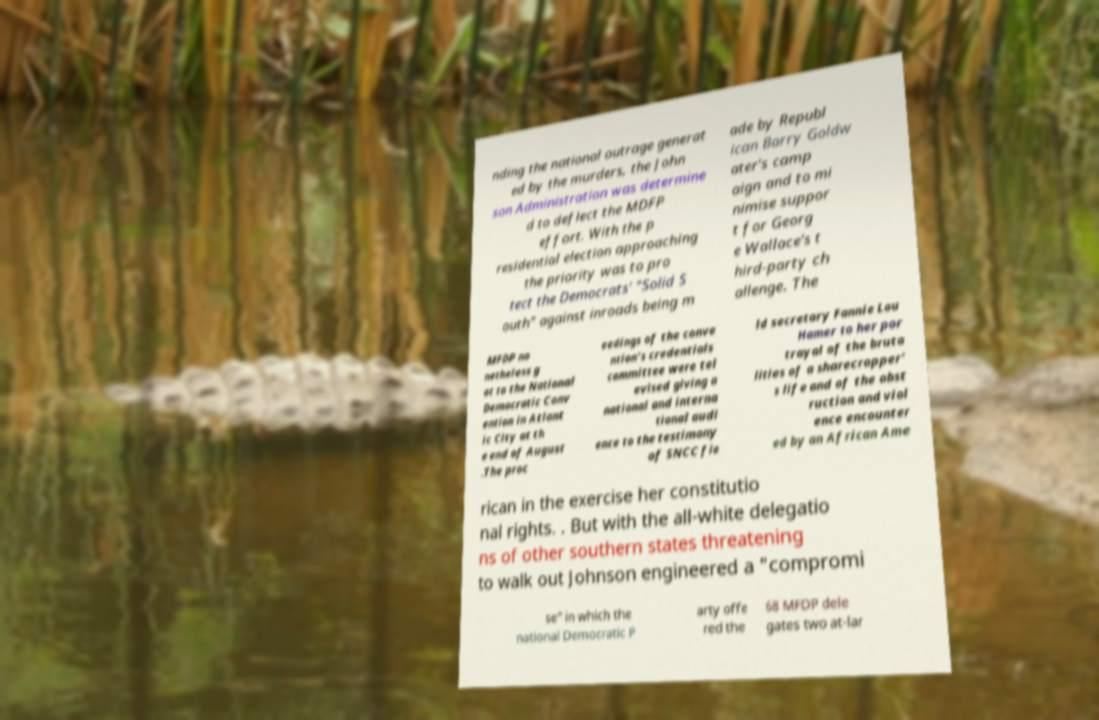Can you read and provide the text displayed in the image?This photo seems to have some interesting text. Can you extract and type it out for me? nding the national outrage generat ed by the murders, the John son Administration was determine d to deflect the MDFP effort. With the p residential election approaching the priority was to pro tect the Democrats' "Solid S outh" against inroads being m ade by Republ ican Barry Goldw ater's camp aign and to mi nimise suppor t for Georg e Wallace's t hird-party ch allenge. The MFDP no netheless g ot to the National Democratic Conv ention in Atlant ic City at th e end of August .The proc eedings of the conve ntion's credentials committee were tel evised giving a national and interna tional audi ence to the testimony of SNCC fie ld secretary Fannie Lou Hamer to her por trayal of the bruta lities of a sharecropper' s life and of the obst ruction and viol ence encounter ed by an African Ame rican in the exercise her constitutio nal rights. . But with the all-white delegatio ns of other southern states threatening to walk out Johnson engineered a "compromi se" in which the national Democratic P arty offe red the 68 MFDP dele gates two at-lar 